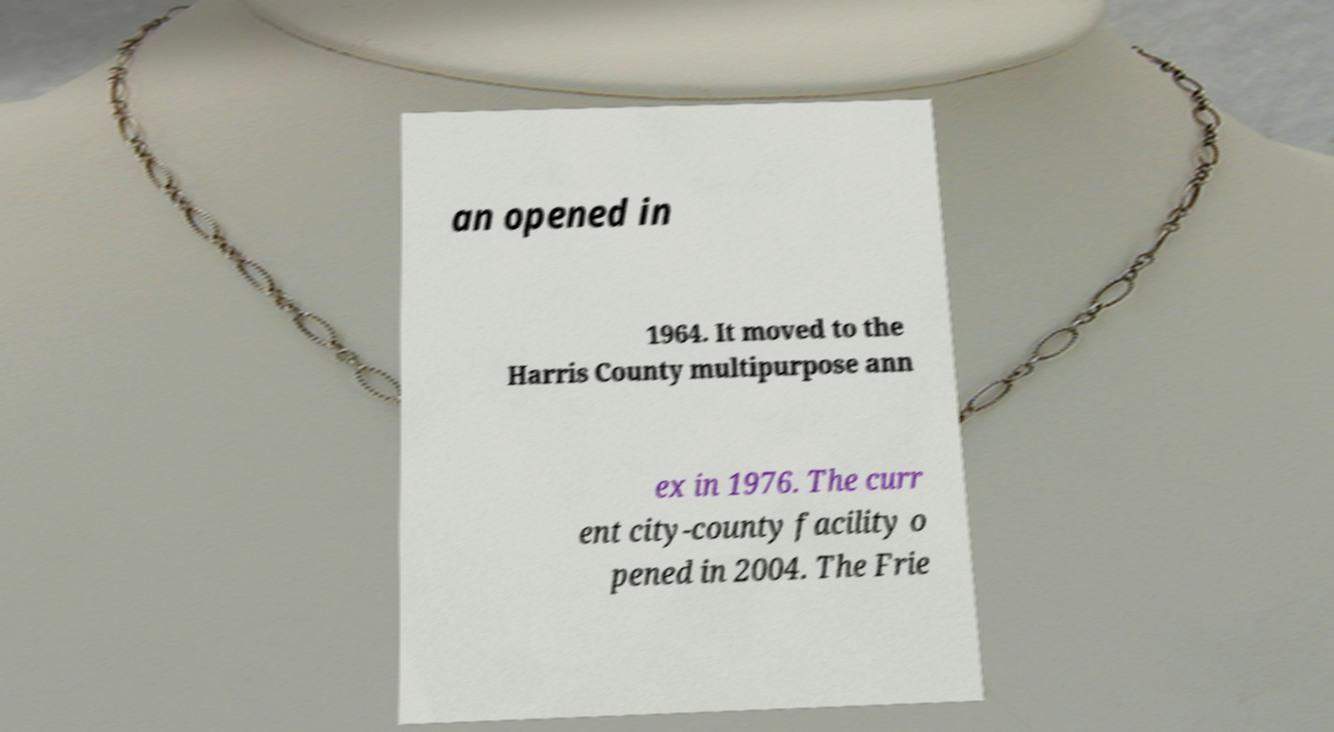Can you accurately transcribe the text from the provided image for me? an opened in 1964. It moved to the Harris County multipurpose ann ex in 1976. The curr ent city-county facility o pened in 2004. The Frie 